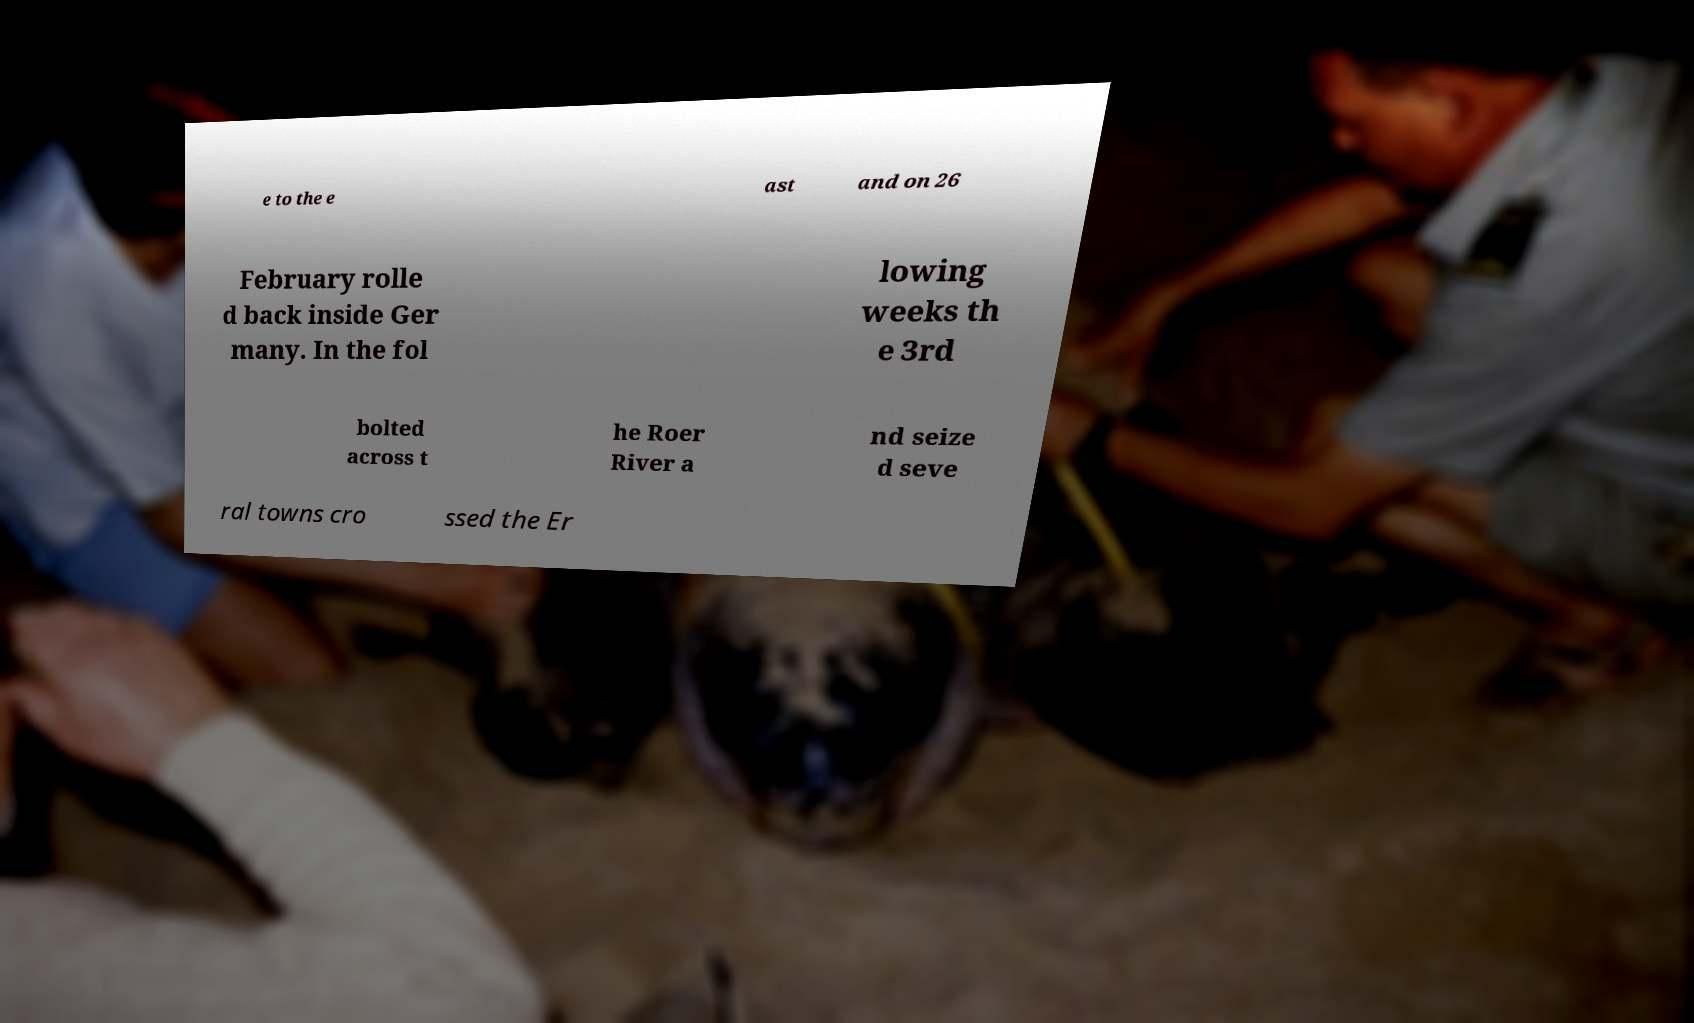I need the written content from this picture converted into text. Can you do that? e to the e ast and on 26 February rolle d back inside Ger many. In the fol lowing weeks th e 3rd bolted across t he Roer River a nd seize d seve ral towns cro ssed the Er 